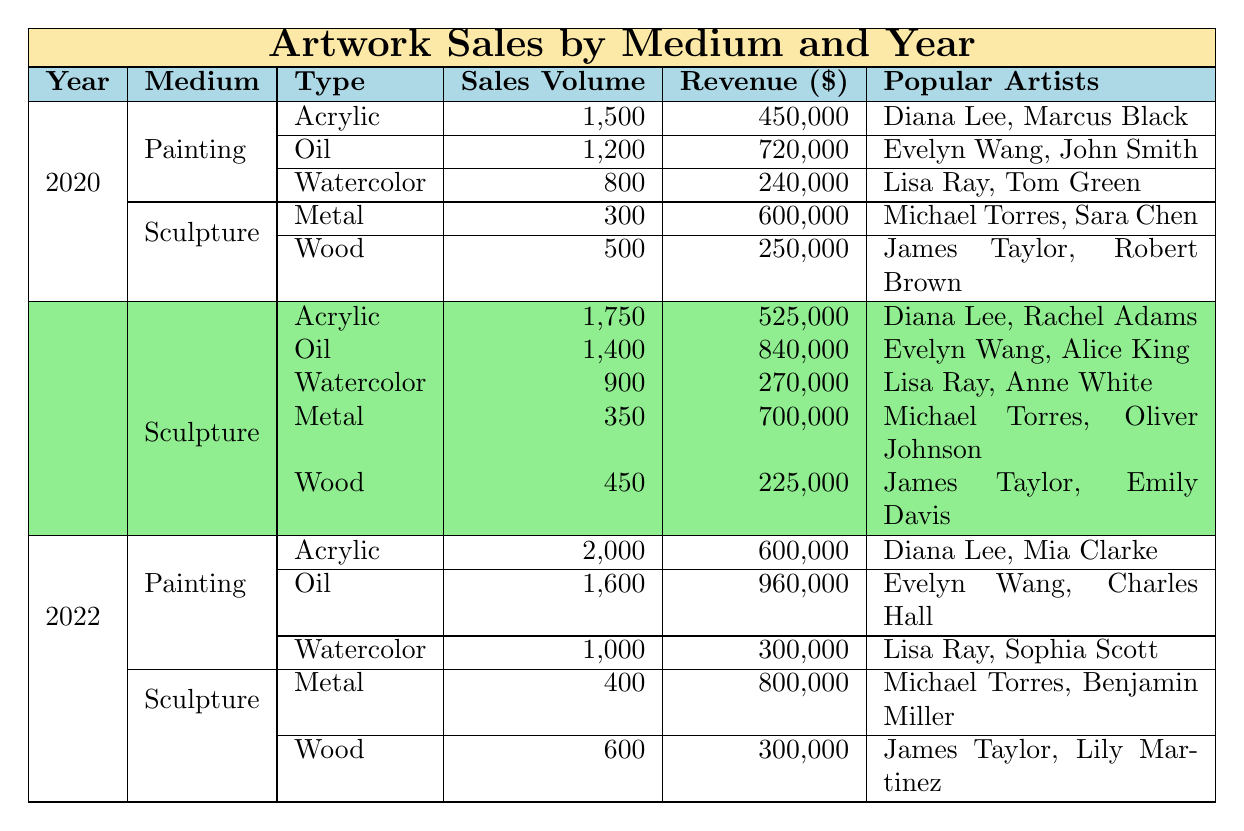What is the sales volume for Acrylic paintings in 2021? The table shows the sales volume for Acrylic paintings in the row corresponding to 2021. For Acrylic, the sales volume is listed as 1,750.
Answer: 1,750 Which medium had the highest revenue in 2022? In 2022, if we compare the revenue for each medium, the highest revenue for Painting is $960,000 for Oil and Sculpture has a maximum of $800,000 for Metal. The highest among these is Oil under Painting at $960,000.
Answer: Oil How many more units of Wood sculptures sold in 2020 compared to 2021? From the table, in 2020, the sales volume for Wood sculptures is 500 and for 2021 it is 450. To find the difference, subtract 450 from 500, resulting in 50.
Answer: 50 Did the sales volume for Watercolor paintings increase from 2020 to 2022? The sales volume for Watercolor paintings is 800 in 2020 and 1,000 in 2022. Since 1,000 is greater than 800, it confirms that there was an increase.
Answer: Yes What is the total revenue for Metal sculptures over the years 2020 to 2022? The revenue for Metal sculptures across the years is: $600,000 in 2020, $700,000 in 2021, and $800,000 in 2022. Adding these amounts gives $600,000 + $700,000 + $800,000 = $2,100,000.
Answer: $2,100,000 Which artist appears most frequently in the popular artists list for Acrylic paintings across the years? By examining the popular artists listed for Acrylic paintings from 2020 to 2022, Diana Lee is mentioned in 2020 (Diana Lee, Marcus Black), 2021 (Diana Lee, Rachel Adams), and 2022 (Diana Lee, Mia Clarke). No other artist appears for all three years. Hence, Diana Lee appears most frequently.
Answer: Diana Lee 